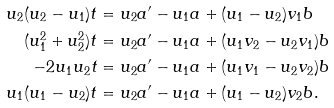<formula> <loc_0><loc_0><loc_500><loc_500>u _ { 2 } ( u _ { 2 } - u _ { 1 } ) t & = u _ { 2 } a ^ { \prime } - u _ { 1 } a + ( u _ { 1 } - u _ { 2 } ) v _ { 1 } b \\ ( u _ { 1 } ^ { 2 } + u _ { 2 } ^ { 2 } ) t & = u _ { 2 } a ^ { \prime } - u _ { 1 } a + ( u _ { 1 } v _ { 2 } - u _ { 2 } v _ { 1 } ) b \\ - 2 u _ { 1 } u _ { 2 } t & = u _ { 2 } a ^ { \prime } - u _ { 1 } a + ( u _ { 1 } v _ { 1 } - u _ { 2 } v _ { 2 } ) b \\ u _ { 1 } ( u _ { 1 } - u _ { 2 } ) t & = u _ { 2 } a ^ { \prime } - u _ { 1 } a + ( u _ { 1 } - u _ { 2 } ) v _ { 2 } b .</formula> 